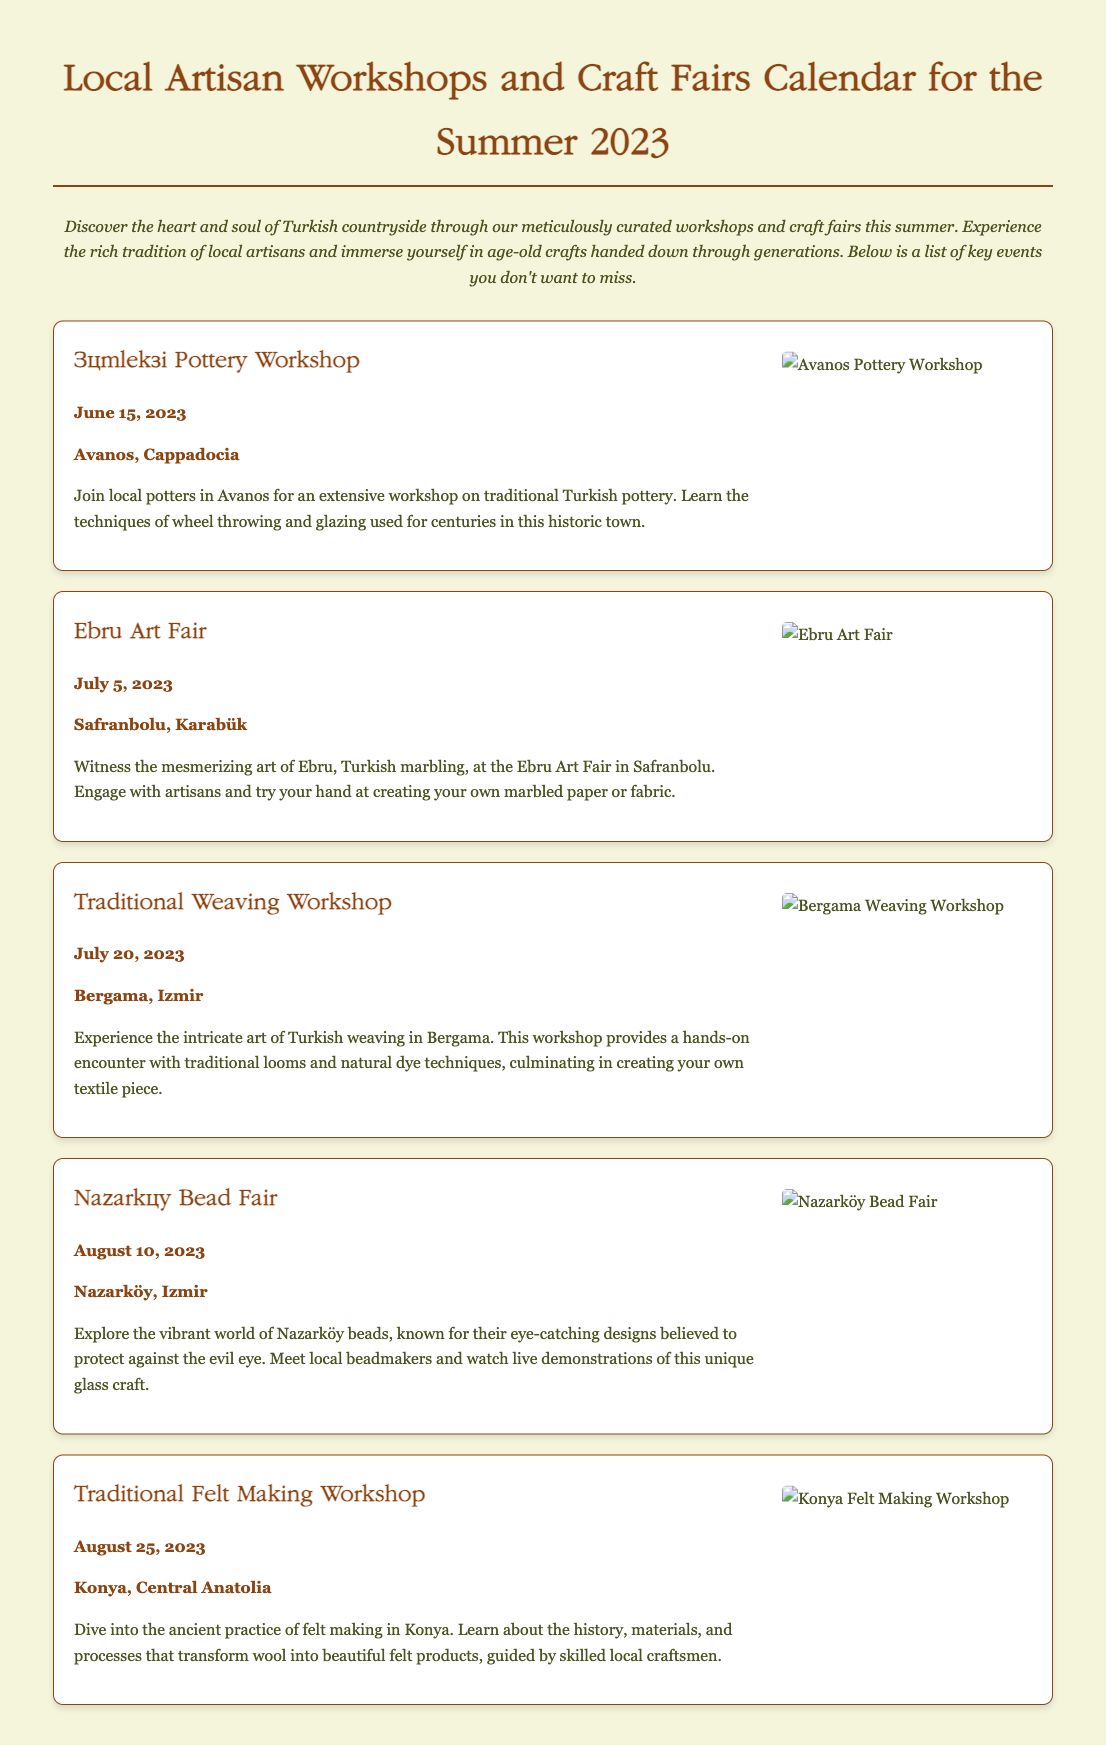What is the title of the document? The title is presented at the top of the document, which is "Local Artisan Workshops and Craft Fairs Calendar for the Summer 2023."
Answer: Local Artisan Workshops and Craft Fairs Calendar for the Summer 2023 How many workshops or fairs are listed in the document? The document lists five separate events, each with its own description and details.
Answer: Five What is the date of the Ebru Art Fair? The specific date for the Ebru Art Fair is stated within its section, which is July 5, 2023.
Answer: July 5, 2023 Where is the Traditional Weaving Workshop held? The location of the Traditional Weaving Workshop is mentioned as Bergama, Izmir.
Answer: Bergama, Izmir Which craft involves creating marbled paper? The document specifies the Ebru Art Fair as the event where attendees can engage with this particular craft.
Answer: Ebru Art Fair What type of textile will participants create in the Traditional Weaving Workshop? The participants in the workshop will create their own textile piece as mentioned in the description.
Answer: Textile piece Which event features beadmaking demonstrations? The Nazarköy Bead Fair includes live demonstrations of beadmaking as stated in its description.
Answer: Nazarköy Bead Fair When does the Traditional Felt Making Workshop take place? The date for the Traditional Felt Making Workshop is provided as August 25, 2023.
Answer: August 25, 2023 